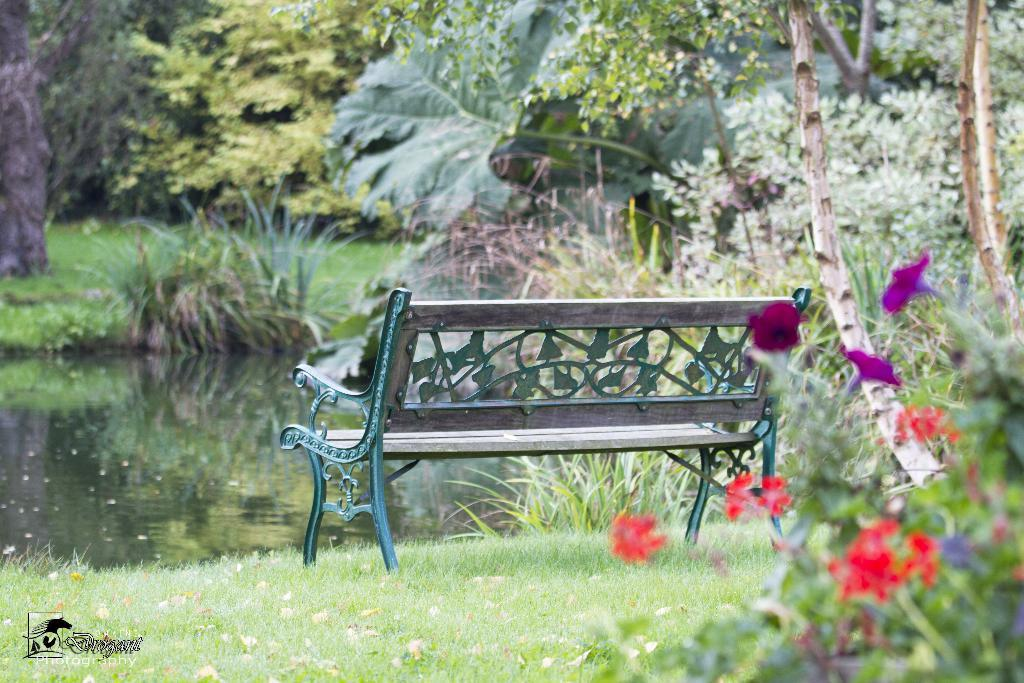What type of seating is present in the image? There is a bench in the image. What type of vegetation can be seen in the image? There is grass, plants, and trees visible in the image. Are there any flowers present in the image? Yes, there are flowers in the image. What else can be seen in the image besides the bench and vegetation? There is water visible in the image. How many ants can be seen crawling on the cup in the image? There is no cup present in the image, and therefore no ants can be seen crawling on it. 